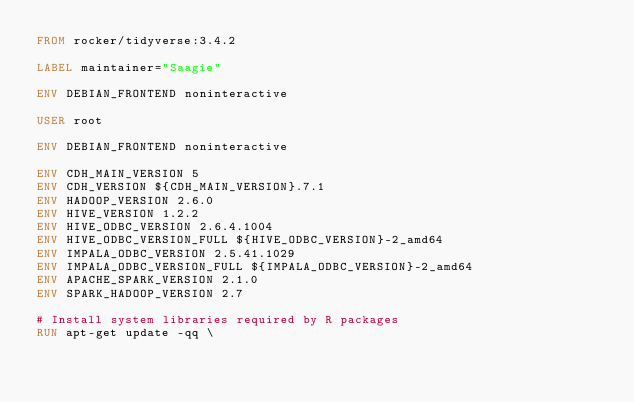<code> <loc_0><loc_0><loc_500><loc_500><_Dockerfile_>FROM rocker/tidyverse:3.4.2

LABEL maintainer="Saagie"

ENV DEBIAN_FRONTEND noninteractive

USER root

ENV DEBIAN_FRONTEND noninteractive

ENV CDH_MAIN_VERSION 5
ENV CDH_VERSION ${CDH_MAIN_VERSION}.7.1
ENV HADOOP_VERSION 2.6.0
ENV HIVE_VERSION 1.2.2
ENV HIVE_ODBC_VERSION 2.6.4.1004
ENV HIVE_ODBC_VERSION_FULL ${HIVE_ODBC_VERSION}-2_amd64
ENV IMPALA_ODBC_VERSION 2.5.41.1029
ENV IMPALA_ODBC_VERSION_FULL ${IMPALA_ODBC_VERSION}-2_amd64
ENV APACHE_SPARK_VERSION 2.1.0
ENV SPARK_HADOOP_VERSION 2.7

# Install system libraries required by R packages
RUN apt-get update -qq \</code> 